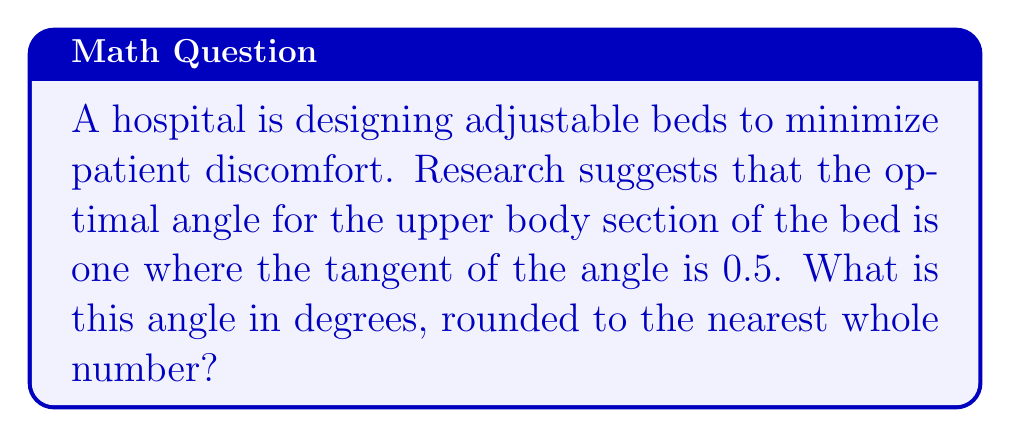Can you solve this math problem? To solve this problem, we'll use the inverse tangent (arctangent) function. Let's approach this step-by-step:

1) We're given that the tangent of the optimal angle is 0.5:
   
   $$\tan(\theta) = 0.5$$

2) To find the angle $\theta$, we need to apply the inverse tangent function to both sides:
   
   $$\theta = \tan^{-1}(0.5)$$

3) Using a calculator or trigonometric tables, we can evaluate this:
   
   $$\theta \approx 0.4636476 \text{ radians}$$

4) However, we need the answer in degrees. To convert from radians to degrees, we multiply by $\frac{180}{\pi}$:

   $$\theta \approx 0.4636476 \times \frac{180}{\pi} \approx 26.5651°$$

5) Rounding to the nearest whole number:

   $$\theta \approx 27°$$

Therefore, the optimal angle for the upper body section of the hospital bed is approximately 27 degrees.
Answer: 27° 